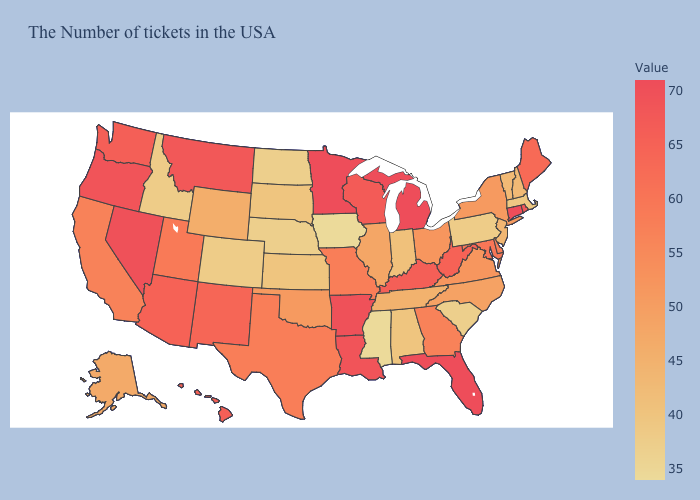Among the states that border Connecticut , which have the lowest value?
Concise answer only. Massachusetts. Does the map have missing data?
Short answer required. No. Among the states that border Rhode Island , does Connecticut have the highest value?
Answer briefly. Yes. Does the map have missing data?
Keep it brief. No. 